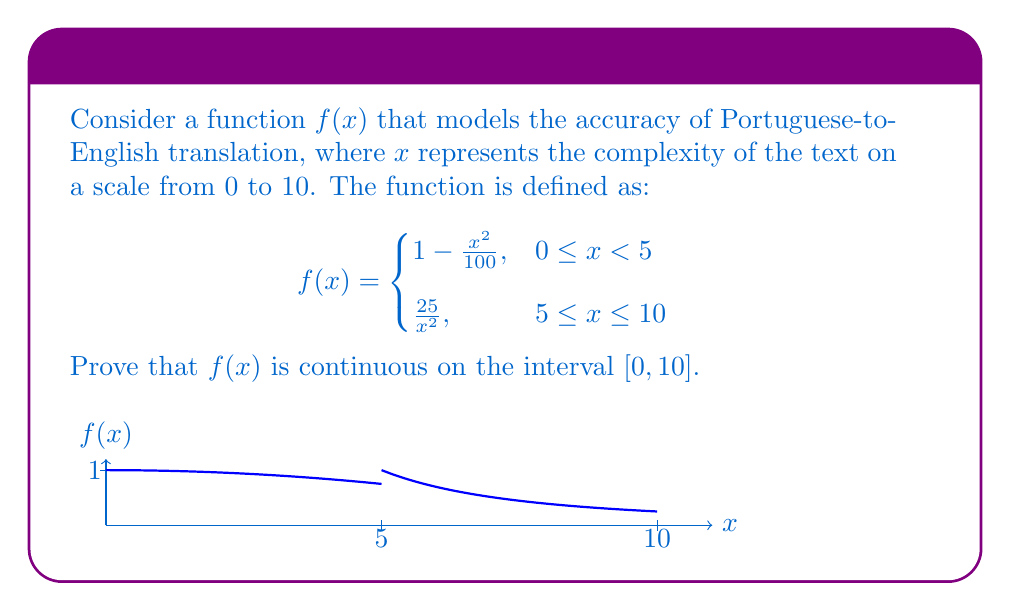Can you answer this question? To prove that $f(x)$ is continuous on $[0, 10]$, we need to show:
1. $f(x)$ is continuous on $(0, 5)$ and $(5, 10)$
2. $f(x)$ is continuous at $x = 5$
3. $f(x)$ is continuous at the endpoints $x = 0$ and $x = 10$

Step 1: Continuity on $(0, 5)$ and $(5, 10)$
Both pieces of $f(x)$ are compositions of continuous functions (polynomials and rational functions), so they are continuous on their respective open intervals.

Step 2: Continuity at $x = 5$
To prove continuity at $x = 5$, we need to show that the left-hand limit, right-hand limit, and function value at $x = 5$ are equal.

Left-hand limit:
$$\lim_{x \to 5^-} f(x) = \lim_{x \to 5^-} (1 - \frac{x^2}{100}) = 1 - \frac{25}{100} = 0.75$$

Right-hand limit:
$$\lim_{x \to 5^+} f(x) = \lim_{x \to 5^+} \frac{25}{x^2} = \frac{25}{25} = 1$$

Function value at $x = 5$:
$$f(5) = \frac{25}{5^2} = 1$$

Since the right-hand limit and function value at $x = 5$ are equal, $f(x)$ is right-continuous at $x = 5$. However, the left-hand limit does not equal the function value, so $f(x)$ is not left-continuous at $x = 5$. Therefore, $f(x)$ is not continuous at $x = 5$.

Step 3: Continuity at endpoints
At $x = 0$: $\lim_{x \to 0^+} f(x) = 1 = f(0)$, so $f(x)$ is continuous at $x = 0$.
At $x = 10$: $\lim_{x \to 10^-} f(x) = \frac{25}{100} = 0.25 = f(10)$, so $f(x)$ is continuous at $x = 10$.
Answer: $f(x)$ is not continuous on $[0, 10]$ due to discontinuity at $x = 5$. 